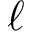Convert formula to latex. <formula><loc_0><loc_0><loc_500><loc_500>\ell</formula> 